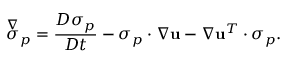Convert formula to latex. <formula><loc_0><loc_0><loc_500><loc_500>\overset { \nabla } { \sigma } _ { p } = \frac { D \sigma _ { p } } { D t } - \sigma _ { p } \cdot \nabla u - \nabla u ^ { T } \cdot \sigma _ { p } .</formula> 